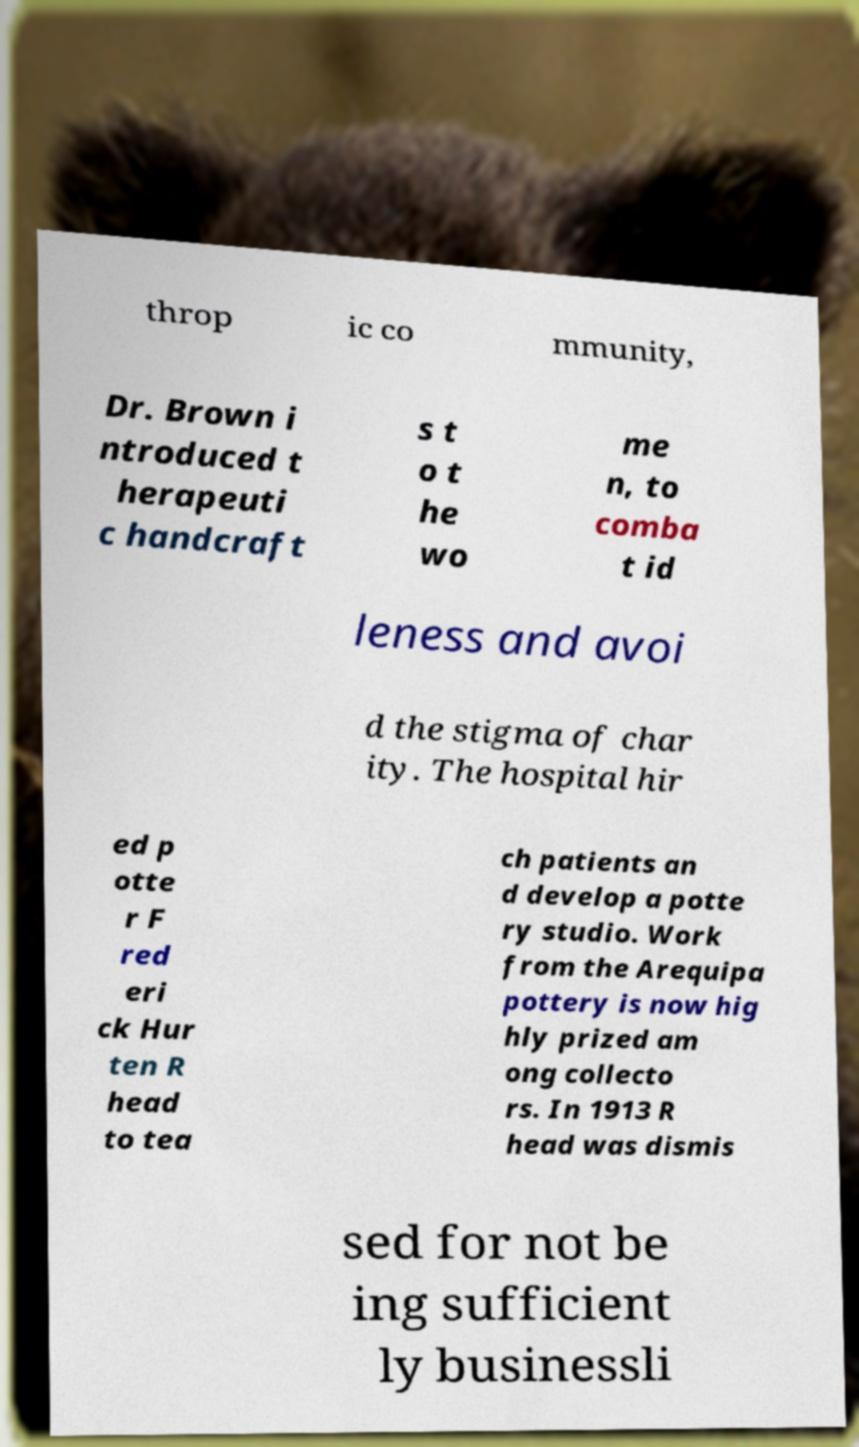For documentation purposes, I need the text within this image transcribed. Could you provide that? throp ic co mmunity, Dr. Brown i ntroduced t herapeuti c handcraft s t o t he wo me n, to comba t id leness and avoi d the stigma of char ity. The hospital hir ed p otte r F red eri ck Hur ten R head to tea ch patients an d develop a potte ry studio. Work from the Arequipa pottery is now hig hly prized am ong collecto rs. In 1913 R head was dismis sed for not be ing sufficient ly businessli 